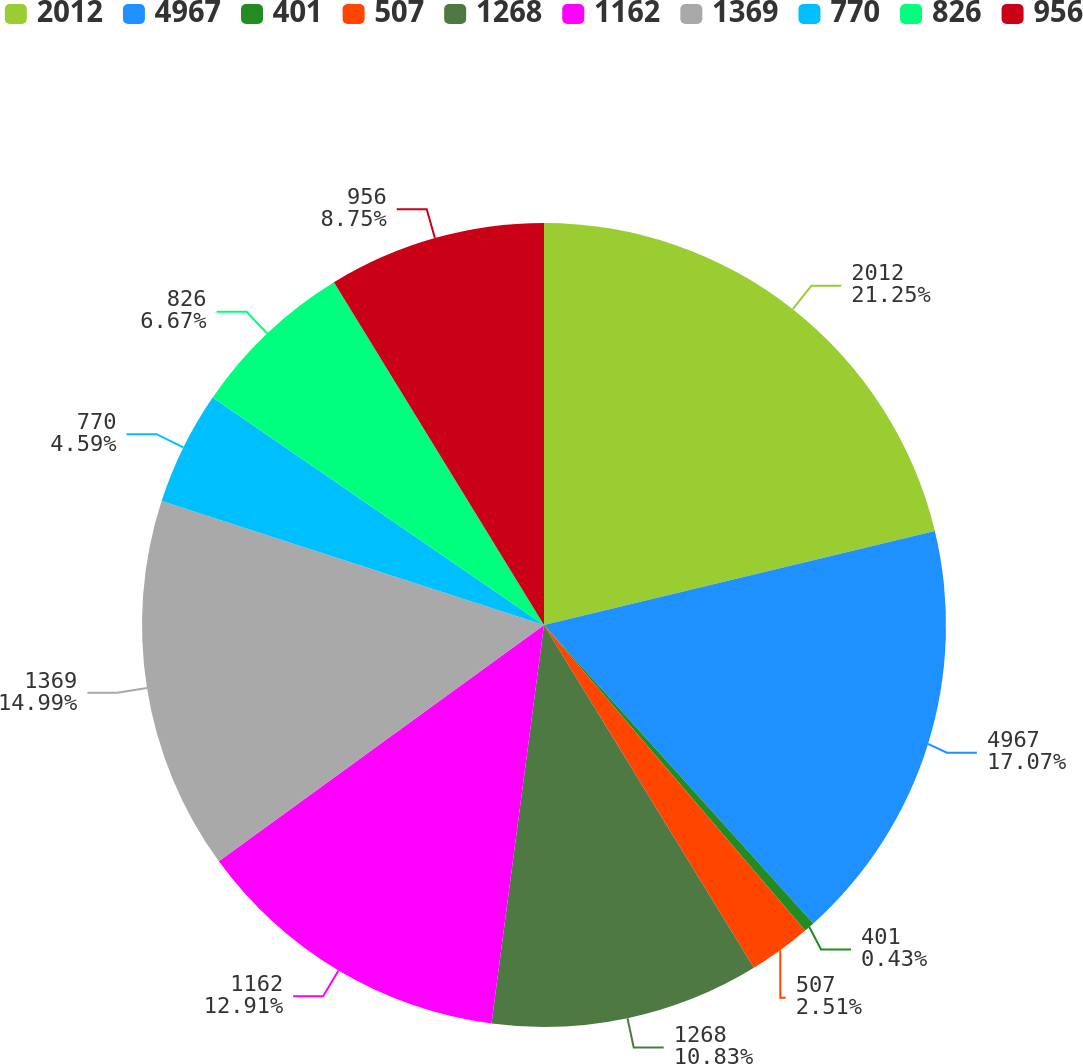<chart> <loc_0><loc_0><loc_500><loc_500><pie_chart><fcel>2012<fcel>4967<fcel>401<fcel>507<fcel>1268<fcel>1162<fcel>1369<fcel>770<fcel>826<fcel>956<nl><fcel>21.24%<fcel>17.07%<fcel>0.43%<fcel>2.51%<fcel>10.83%<fcel>12.91%<fcel>14.99%<fcel>4.59%<fcel>6.67%<fcel>8.75%<nl></chart> 